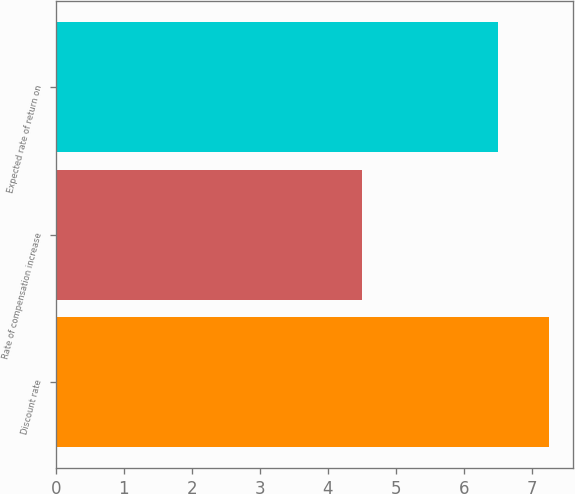Convert chart. <chart><loc_0><loc_0><loc_500><loc_500><bar_chart><fcel>Discount rate<fcel>Rate of compensation increase<fcel>Expected rate of return on<nl><fcel>7.25<fcel>4.5<fcel>6.5<nl></chart> 